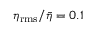<formula> <loc_0><loc_0><loc_500><loc_500>\eta _ { r m s } / { \bar { \eta } } = 0 . 1</formula> 